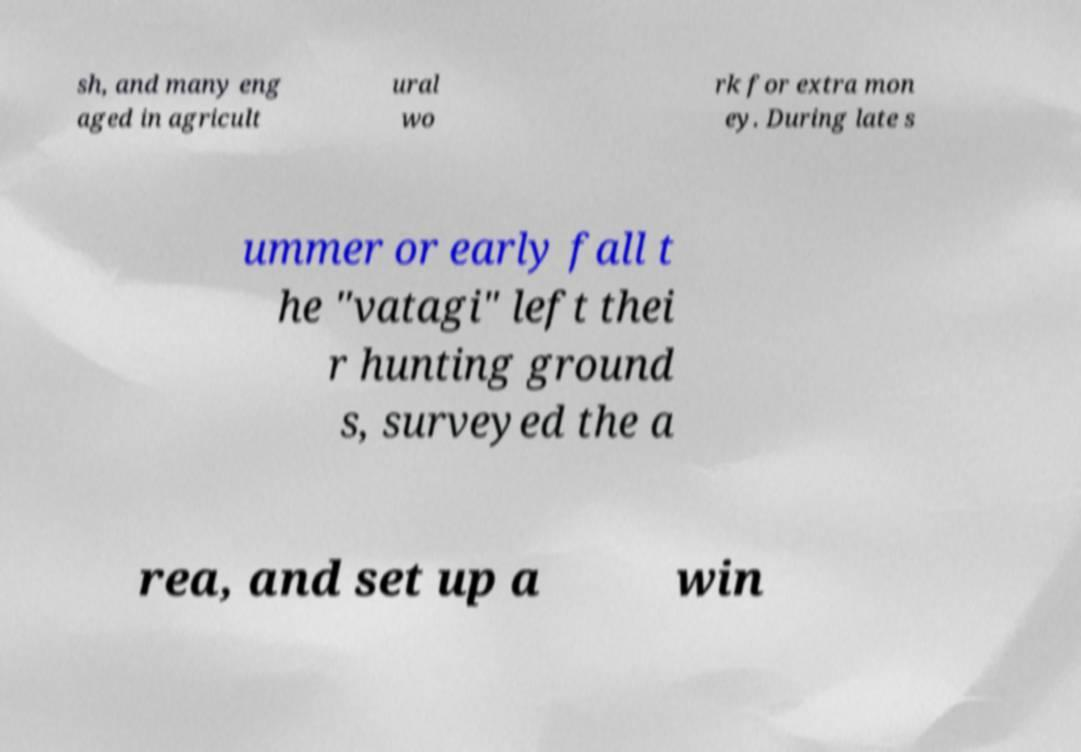Can you read and provide the text displayed in the image?This photo seems to have some interesting text. Can you extract and type it out for me? sh, and many eng aged in agricult ural wo rk for extra mon ey. During late s ummer or early fall t he "vatagi" left thei r hunting ground s, surveyed the a rea, and set up a win 